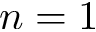Convert formula to latex. <formula><loc_0><loc_0><loc_500><loc_500>n = 1</formula> 